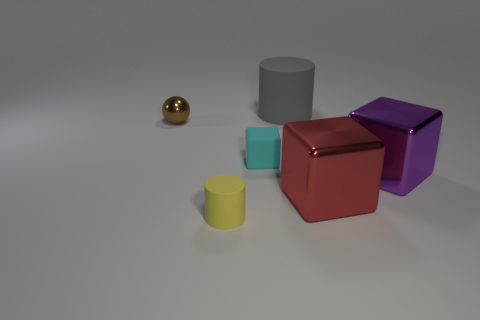Add 2 small things. How many objects exist? 8 Subtract all cylinders. How many objects are left? 4 Add 1 tiny cyan metal cylinders. How many tiny cyan metal cylinders exist? 1 Subtract 1 cyan cubes. How many objects are left? 5 Subtract all small blue matte cylinders. Subtract all small cyan things. How many objects are left? 5 Add 5 big objects. How many big objects are left? 8 